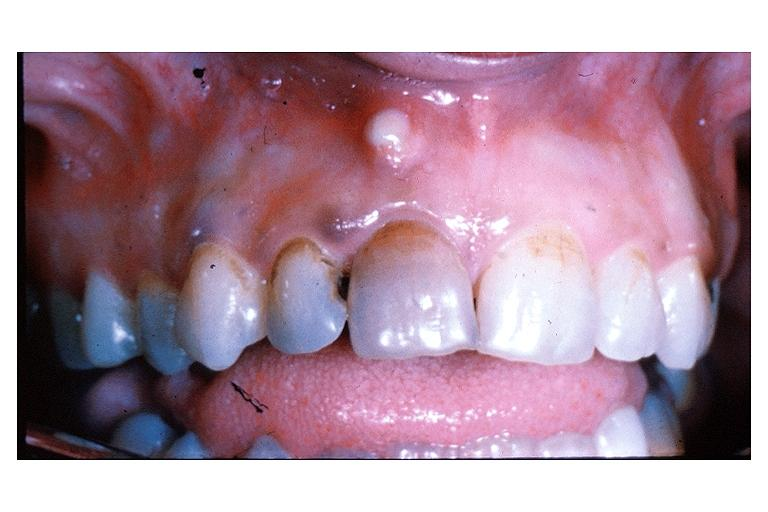does this image show parulis acute alveolar abscess?
Answer the question using a single word or phrase. Yes 